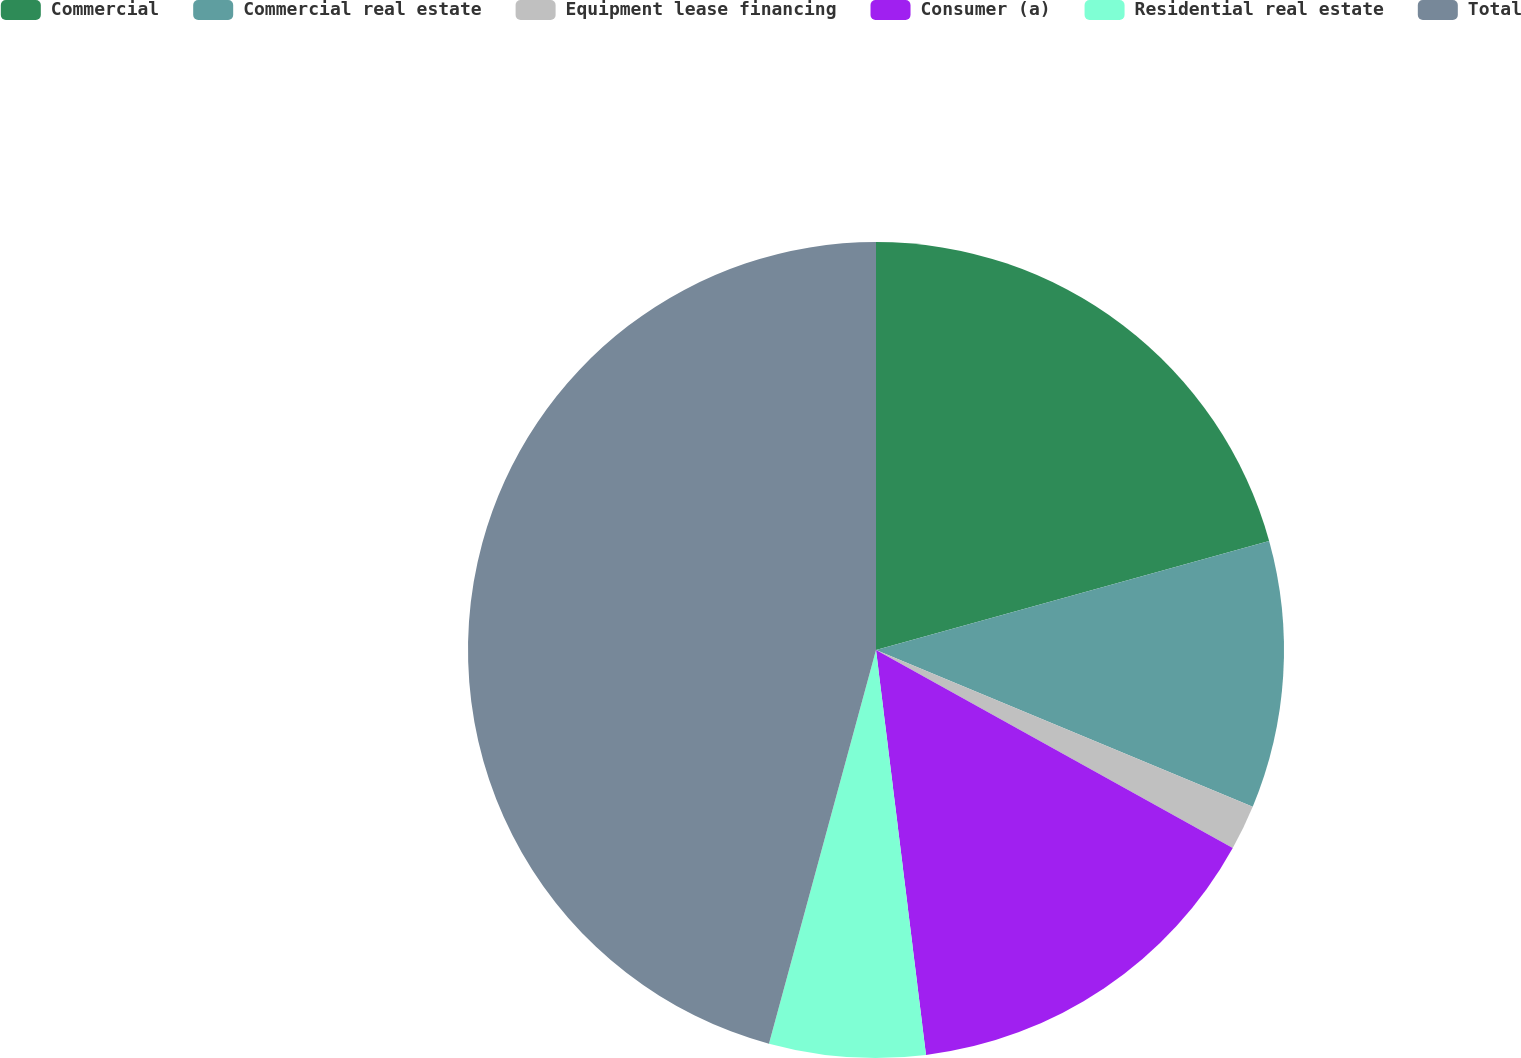Convert chart to OTSL. <chart><loc_0><loc_0><loc_500><loc_500><pie_chart><fcel>Commercial<fcel>Commercial real estate<fcel>Equipment lease financing<fcel>Consumer (a)<fcel>Residential real estate<fcel>Total<nl><fcel>20.69%<fcel>10.58%<fcel>1.79%<fcel>14.98%<fcel>6.18%<fcel>45.77%<nl></chart> 